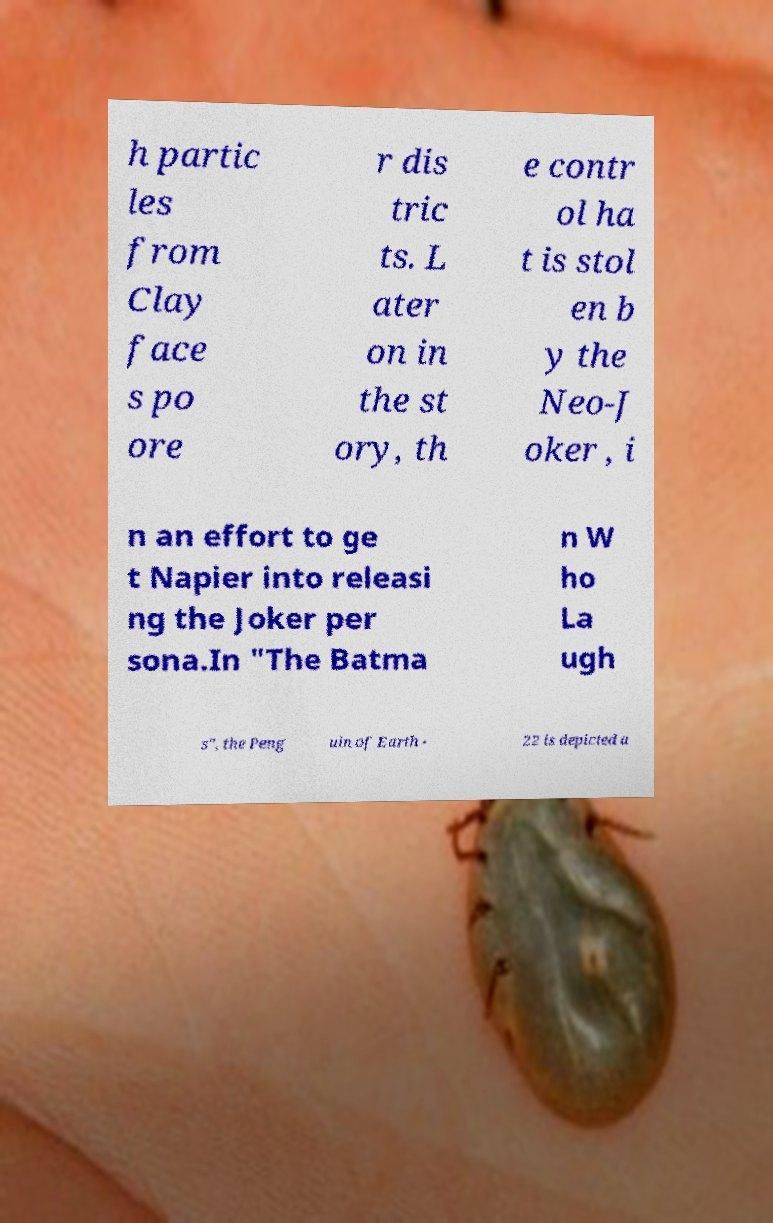Could you extract and type out the text from this image? h partic les from Clay face s po ore r dis tric ts. L ater on in the st ory, th e contr ol ha t is stol en b y the Neo-J oker , i n an effort to ge t Napier into releasi ng the Joker per sona.In "The Batma n W ho La ugh s", the Peng uin of Earth - 22 is depicted a 